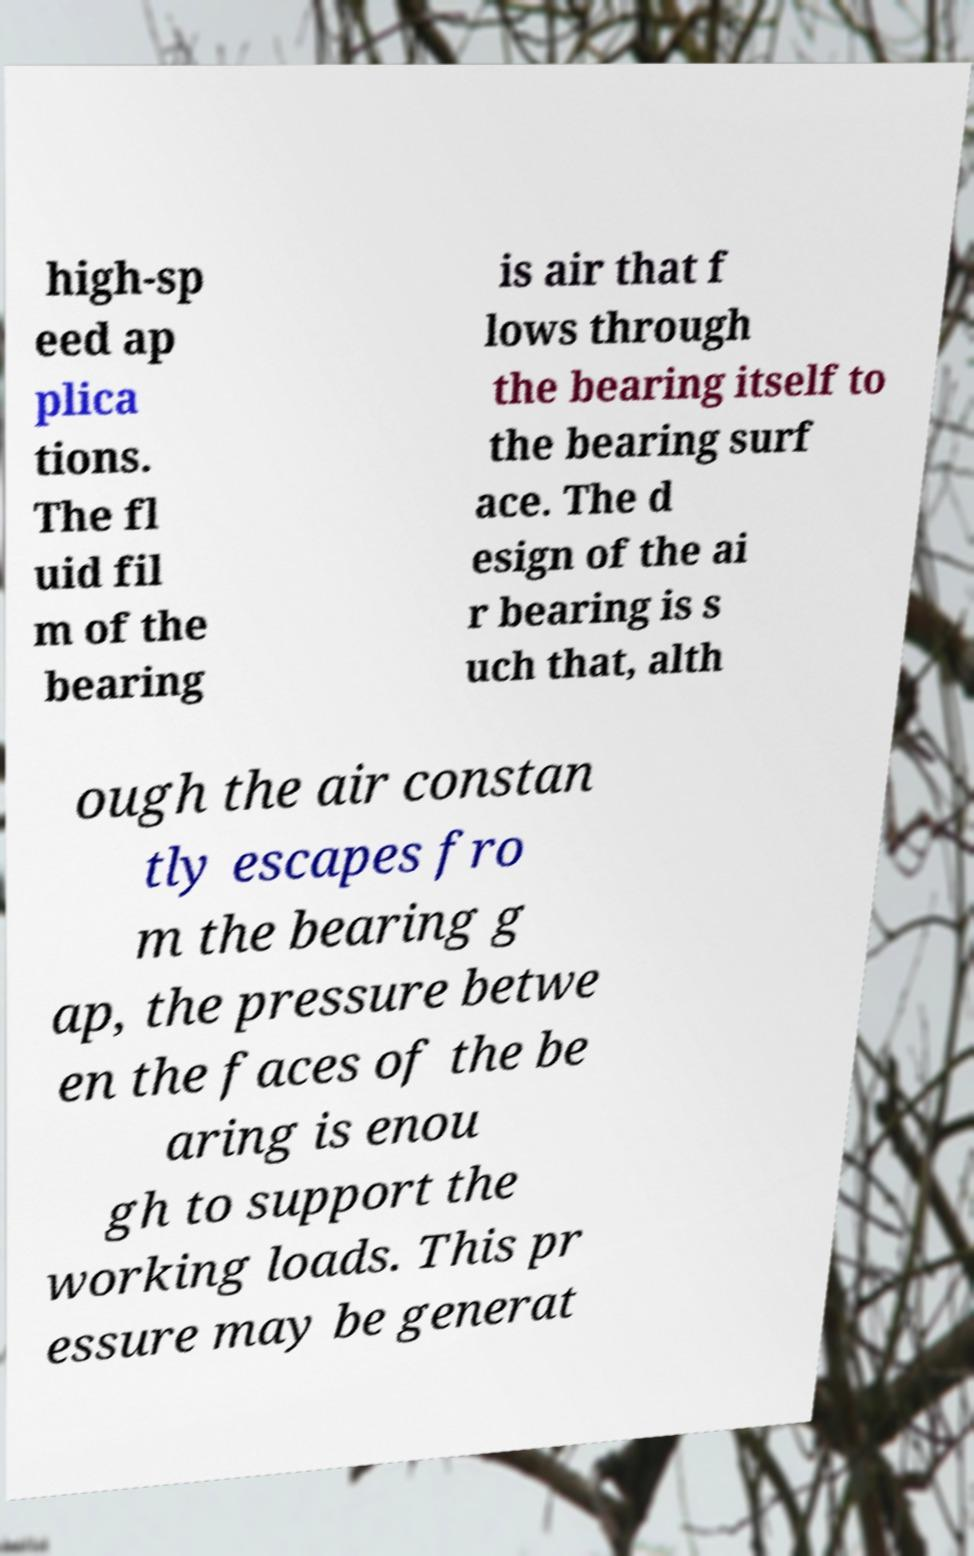Can you read and provide the text displayed in the image?This photo seems to have some interesting text. Can you extract and type it out for me? high-sp eed ap plica tions. The fl uid fil m of the bearing is air that f lows through the bearing itself to the bearing surf ace. The d esign of the ai r bearing is s uch that, alth ough the air constan tly escapes fro m the bearing g ap, the pressure betwe en the faces of the be aring is enou gh to support the working loads. This pr essure may be generat 